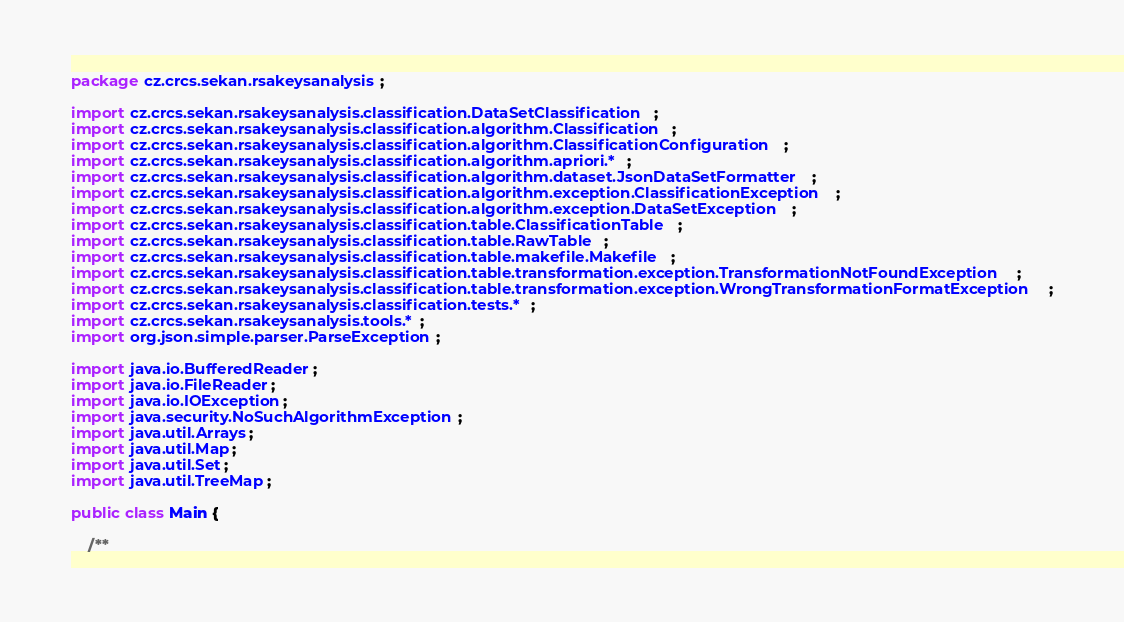<code> <loc_0><loc_0><loc_500><loc_500><_Java_>package cz.crcs.sekan.rsakeysanalysis;

import cz.crcs.sekan.rsakeysanalysis.classification.DataSetClassification;
import cz.crcs.sekan.rsakeysanalysis.classification.algorithm.Classification;
import cz.crcs.sekan.rsakeysanalysis.classification.algorithm.ClassificationConfiguration;
import cz.crcs.sekan.rsakeysanalysis.classification.algorithm.apriori.*;
import cz.crcs.sekan.rsakeysanalysis.classification.algorithm.dataset.JsonDataSetFormatter;
import cz.crcs.sekan.rsakeysanalysis.classification.algorithm.exception.ClassificationException;
import cz.crcs.sekan.rsakeysanalysis.classification.algorithm.exception.DataSetException;
import cz.crcs.sekan.rsakeysanalysis.classification.table.ClassificationTable;
import cz.crcs.sekan.rsakeysanalysis.classification.table.RawTable;
import cz.crcs.sekan.rsakeysanalysis.classification.table.makefile.Makefile;
import cz.crcs.sekan.rsakeysanalysis.classification.table.transformation.exception.TransformationNotFoundException;
import cz.crcs.sekan.rsakeysanalysis.classification.table.transformation.exception.WrongTransformationFormatException;
import cz.crcs.sekan.rsakeysanalysis.classification.tests.*;
import cz.crcs.sekan.rsakeysanalysis.tools.*;
import org.json.simple.parser.ParseException;

import java.io.BufferedReader;
import java.io.FileReader;
import java.io.IOException;
import java.security.NoSuchAlgorithmException;
import java.util.Arrays;
import java.util.Map;
import java.util.Set;
import java.util.TreeMap;

public class Main {

    /**</code> 